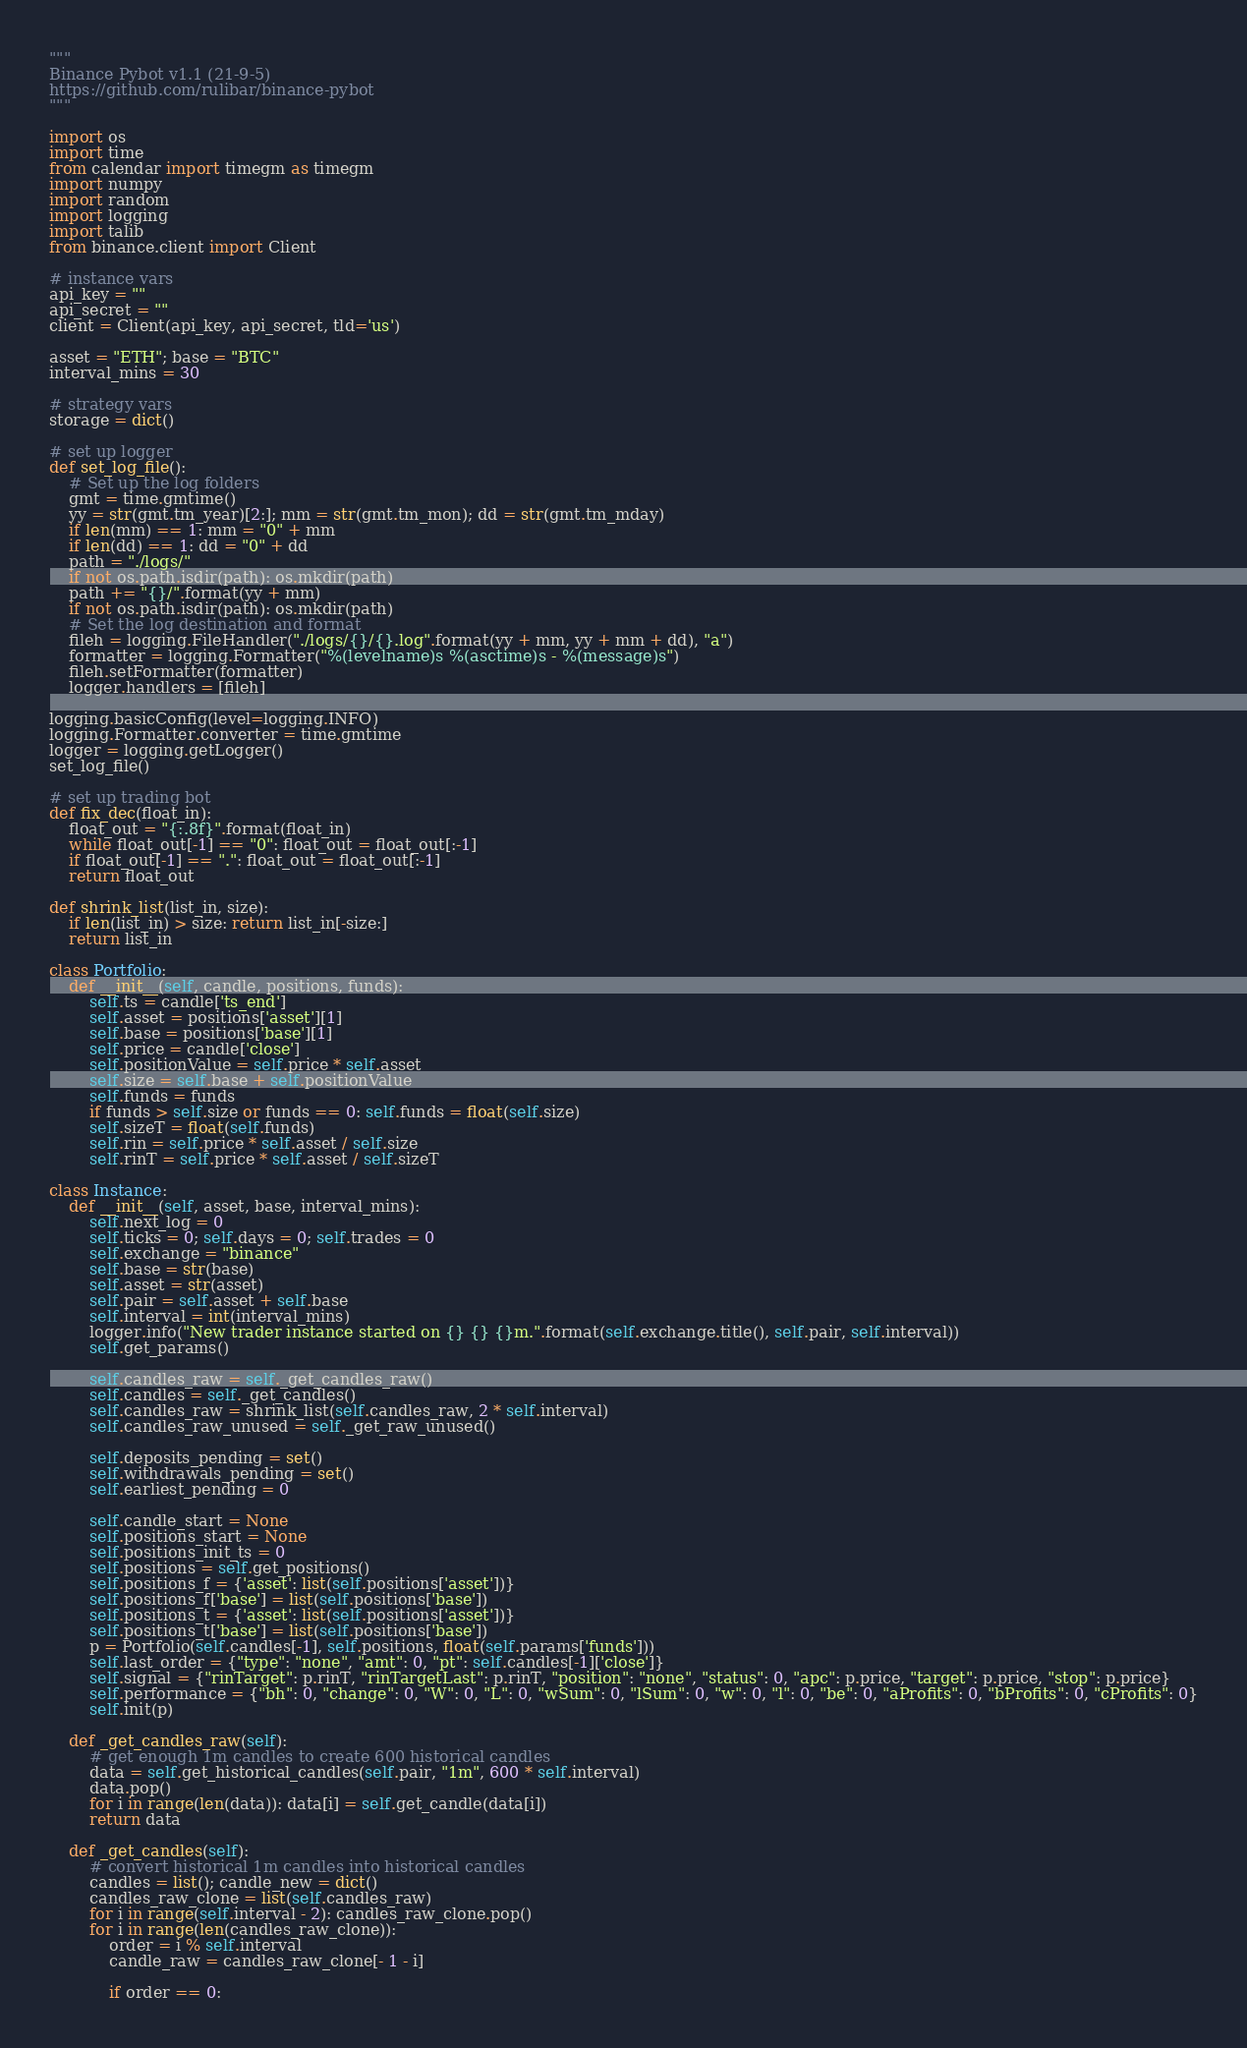<code> <loc_0><loc_0><loc_500><loc_500><_Python_>"""
Binance Pybot v1.1 (21-9-5)
https://github.com/rulibar/binance-pybot
"""

import os
import time
from calendar import timegm as timegm
import numpy
import random
import logging
import talib
from binance.client import Client

# instance vars
api_key = ""
api_secret = ""
client = Client(api_key, api_secret, tld='us')

asset = "ETH"; base = "BTC"
interval_mins = 30

# strategy vars
storage = dict()

# set up logger
def set_log_file():
    # Set up the log folders
    gmt = time.gmtime()
    yy = str(gmt.tm_year)[2:]; mm = str(gmt.tm_mon); dd = str(gmt.tm_mday)
    if len(mm) == 1: mm = "0" + mm
    if len(dd) == 1: dd = "0" + dd
    path = "./logs/"
    if not os.path.isdir(path): os.mkdir(path)
    path += "{}/".format(yy + mm)
    if not os.path.isdir(path): os.mkdir(path)
    # Set the log destination and format
    fileh = logging.FileHandler("./logs/{}/{}.log".format(yy + mm, yy + mm + dd), "a")
    formatter = logging.Formatter("%(levelname)s %(asctime)s - %(message)s")
    fileh.setFormatter(formatter)
    logger.handlers = [fileh]

logging.basicConfig(level=logging.INFO)
logging.Formatter.converter = time.gmtime
logger = logging.getLogger()
set_log_file()

# set up trading bot
def fix_dec(float_in):
    float_out = "{:.8f}".format(float_in)
    while float_out[-1] == "0": float_out = float_out[:-1]
    if float_out[-1] == ".": float_out = float_out[:-1]
    return float_out

def shrink_list(list_in, size):
    if len(list_in) > size: return list_in[-size:]
    return list_in

class Portfolio:
    def __init__(self, candle, positions, funds):
        self.ts = candle['ts_end']
        self.asset = positions['asset'][1]
        self.base = positions['base'][1]
        self.price = candle['close']
        self.positionValue = self.price * self.asset
        self.size = self.base + self.positionValue
        self.funds = funds
        if funds > self.size or funds == 0: self.funds = float(self.size)
        self.sizeT = float(self.funds)
        self.rin = self.price * self.asset / self.size
        self.rinT = self.price * self.asset / self.sizeT

class Instance:
    def __init__(self, asset, base, interval_mins):
        self.next_log = 0
        self.ticks = 0; self.days = 0; self.trades = 0
        self.exchange = "binance"
        self.base = str(base)
        self.asset = str(asset)
        self.pair = self.asset + self.base
        self.interval = int(interval_mins)
        logger.info("New trader instance started on {} {} {}m.".format(self.exchange.title(), self.pair, self.interval))
        self.get_params()

        self.candles_raw = self._get_candles_raw()
        self.candles = self._get_candles()
        self.candles_raw = shrink_list(self.candles_raw, 2 * self.interval)
        self.candles_raw_unused = self._get_raw_unused()

        self.deposits_pending = set()
        self.withdrawals_pending = set()
        self.earliest_pending = 0

        self.candle_start = None
        self.positions_start = None
        self.positions_init_ts = 0
        self.positions = self.get_positions()
        self.positions_f = {'asset': list(self.positions['asset'])}
        self.positions_f['base'] = list(self.positions['base'])
        self.positions_t = {'asset': list(self.positions['asset'])}
        self.positions_t['base'] = list(self.positions['base'])
        p = Portfolio(self.candles[-1], self.positions, float(self.params['funds']))
        self.last_order = {"type": "none", "amt": 0, "pt": self.candles[-1]['close']}
        self.signal = {"rinTarget": p.rinT, "rinTargetLast": p.rinT, "position": "none", "status": 0, "apc": p.price, "target": p.price, "stop": p.price}
        self.performance = {"bh": 0, "change": 0, "W": 0, "L": 0, "wSum": 0, "lSum": 0, "w": 0, "l": 0, "be": 0, "aProfits": 0, "bProfits": 0, "cProfits": 0}
        self.init(p)

    def _get_candles_raw(self):
        # get enough 1m candles to create 600 historical candles
        data = self.get_historical_candles(self.pair, "1m", 600 * self.interval)
        data.pop()
        for i in range(len(data)): data[i] = self.get_candle(data[i])
        return data

    def _get_candles(self):
        # convert historical 1m candles into historical candles
        candles = list(); candle_new = dict()
        candles_raw_clone = list(self.candles_raw)
        for i in range(self.interval - 2): candles_raw_clone.pop()
        for i in range(len(candles_raw_clone)):
            order = i % self.interval
            candle_raw = candles_raw_clone[- 1 - i]

            if order == 0:</code> 